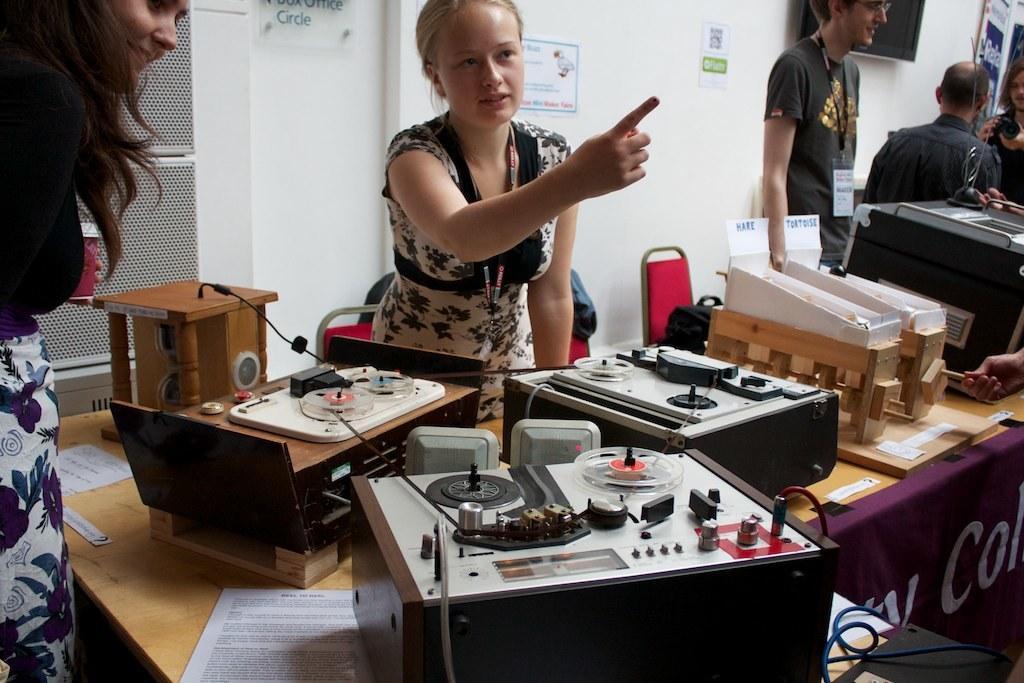Describe this image in one or two sentences. In this picture we can see some persons standing on the floor. This is table. On the table there are some electronic devices. On the background there is a wall. And this is door. 